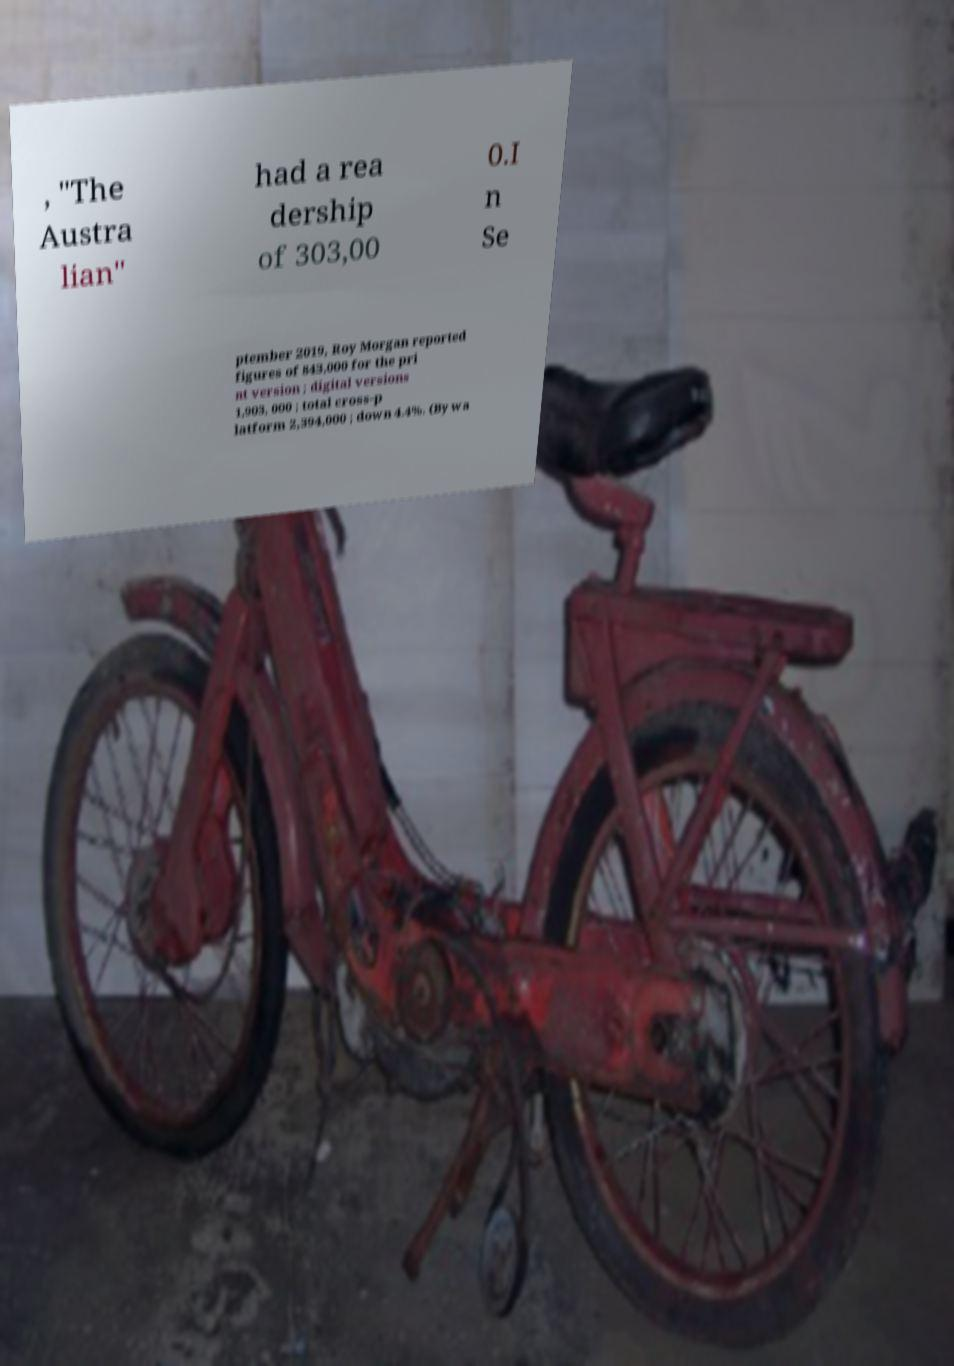Could you assist in decoding the text presented in this image and type it out clearly? , "The Austra lian" had a rea dership of 303,00 0.I n Se ptember 2019, Roy Morgan reported figures of 843,000 for the pri nt version ; digital versions 1,903, 000 ; total cross-p latform 2,394,000 ; down 4.4%. (By wa 